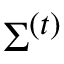<formula> <loc_0><loc_0><loc_500><loc_500>\Sigma ^ { ( t ) }</formula> 